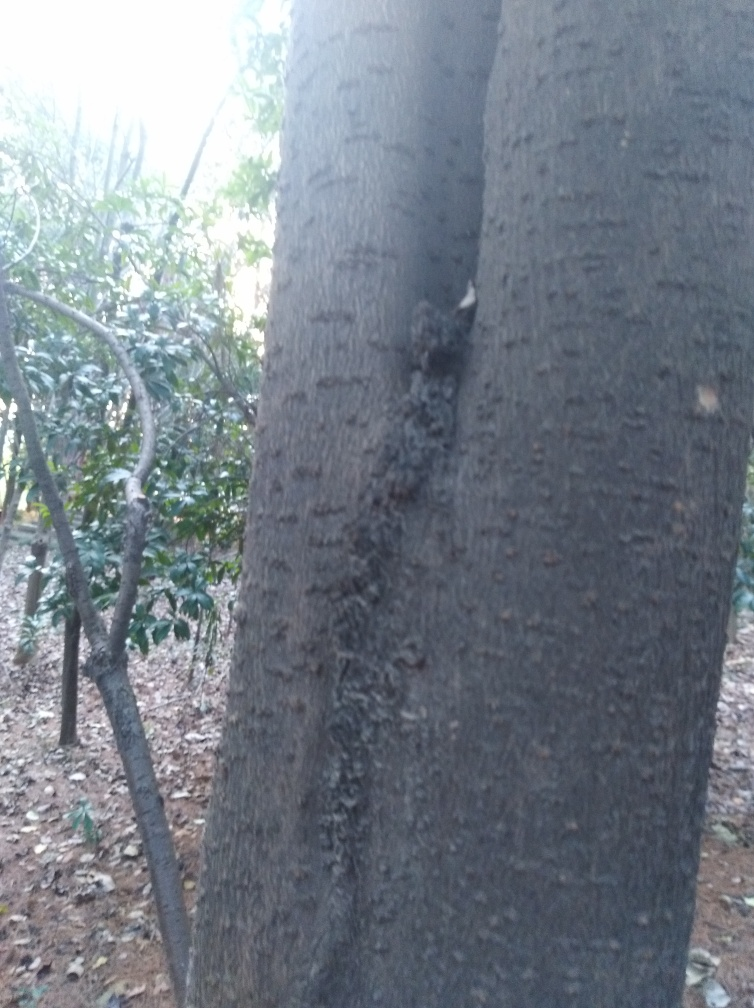Is the focus in this image perfect? The focus in this image is not ideal. The foreground seems slightly out of focus, particularly around the tree bark, which should be sharp in a perfectly focused image. On the other hand, the background appears more in focus, indicating that the depth of field might not be properly set to capture the tree details sharply. 